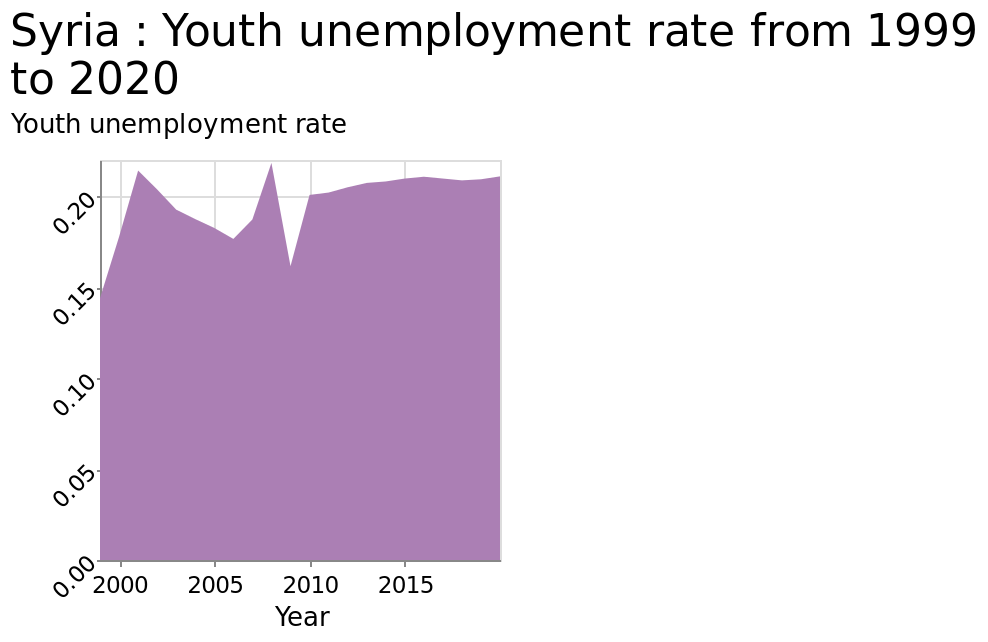<image>
What is the minimum value on the x-axis scale?  The minimum value on the x-axis scale is 2000. What time period does the chart cover?  The chart covers the years from 1999 to 2020. What is the title of the area graph? The title of the area graph is "Syria: Youth unemployment rate from 1999 to 2020." please enumerates aspects of the construction of the chart This is a area graph labeled Syria : Youth unemployment rate from 1999 to 2020. There is a linear scale with a minimum of 2000 and a maximum of 2015 along the x-axis, labeled Year. A linear scale of range 0.00 to 0.20 can be found on the y-axis, marked Youth unemployment rate. What is the label on the x-axis of the area graph?  The label on the x-axis of the area graph is "Year". 